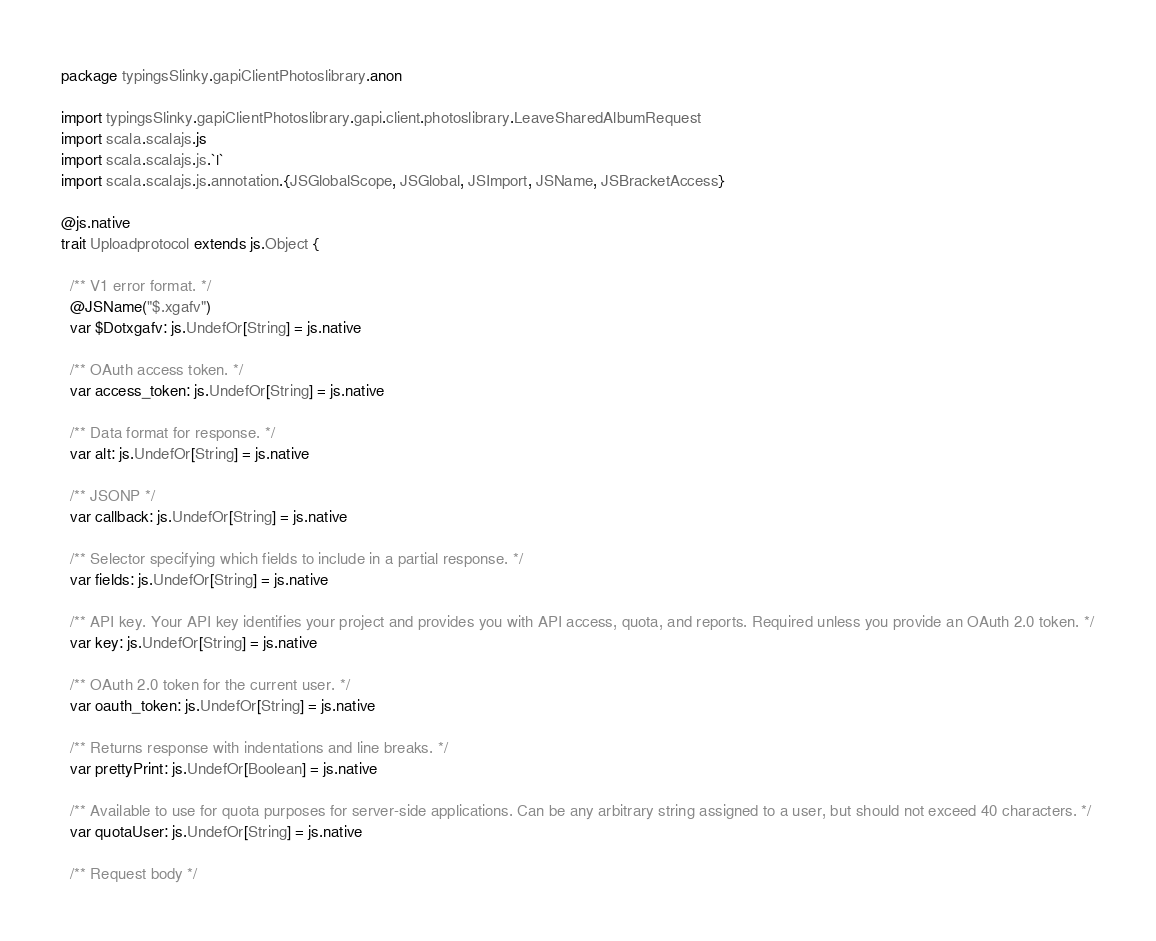Convert code to text. <code><loc_0><loc_0><loc_500><loc_500><_Scala_>package typingsSlinky.gapiClientPhotoslibrary.anon

import typingsSlinky.gapiClientPhotoslibrary.gapi.client.photoslibrary.LeaveSharedAlbumRequest
import scala.scalajs.js
import scala.scalajs.js.`|`
import scala.scalajs.js.annotation.{JSGlobalScope, JSGlobal, JSImport, JSName, JSBracketAccess}

@js.native
trait Uploadprotocol extends js.Object {
  
  /** V1 error format. */
  @JSName("$.xgafv")
  var $Dotxgafv: js.UndefOr[String] = js.native
  
  /** OAuth access token. */
  var access_token: js.UndefOr[String] = js.native
  
  /** Data format for response. */
  var alt: js.UndefOr[String] = js.native
  
  /** JSONP */
  var callback: js.UndefOr[String] = js.native
  
  /** Selector specifying which fields to include in a partial response. */
  var fields: js.UndefOr[String] = js.native
  
  /** API key. Your API key identifies your project and provides you with API access, quota, and reports. Required unless you provide an OAuth 2.0 token. */
  var key: js.UndefOr[String] = js.native
  
  /** OAuth 2.0 token for the current user. */
  var oauth_token: js.UndefOr[String] = js.native
  
  /** Returns response with indentations and line breaks. */
  var prettyPrint: js.UndefOr[Boolean] = js.native
  
  /** Available to use for quota purposes for server-side applications. Can be any arbitrary string assigned to a user, but should not exceed 40 characters. */
  var quotaUser: js.UndefOr[String] = js.native
  
  /** Request body */</code> 